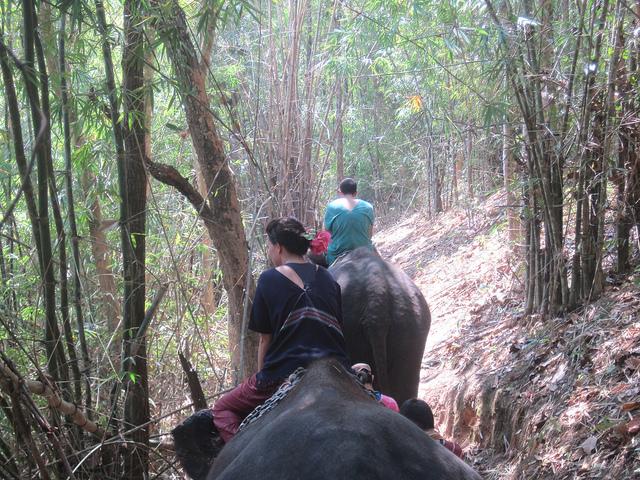How many animals?
Keep it brief. 2. Are they riding in the jungle?
Answer briefly. Yes. What are they riding?
Concise answer only. Elephants. 